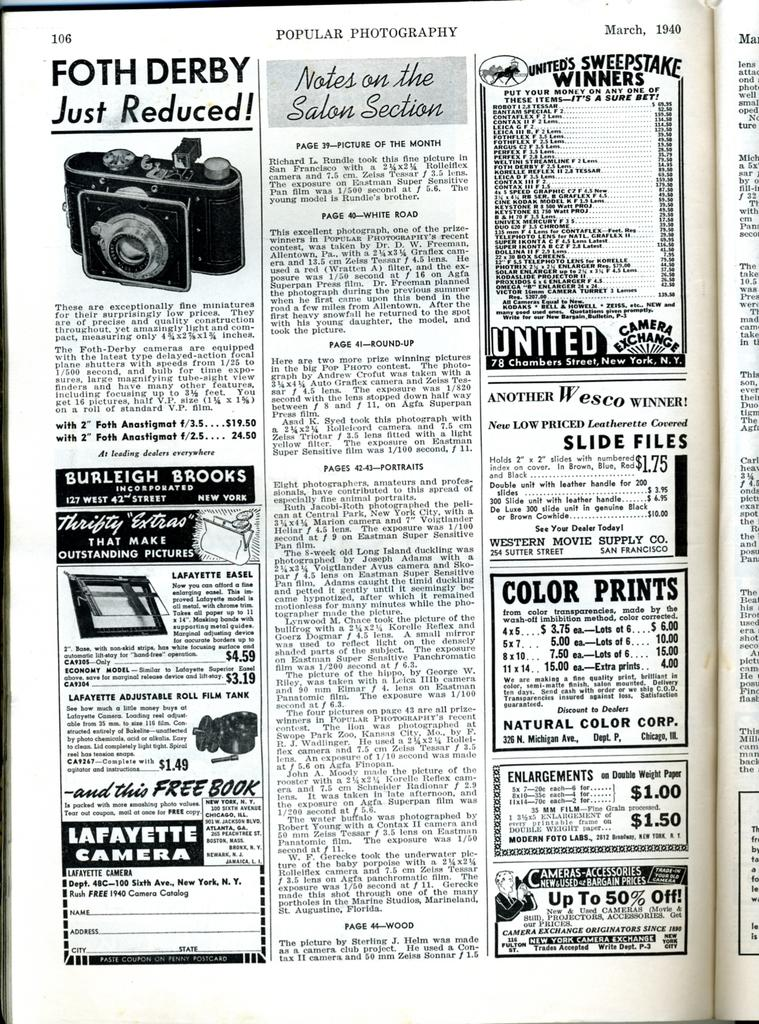What is present in the image that contains information? There is a paper in the image that contains information. What types of content can be found on the paper? The paper contains both text and images. What type of pain is depicted on the face of the person in the image? There is no person or face present in the image, as it only contains a paper with text and images. 